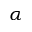Convert formula to latex. <formula><loc_0><loc_0><loc_500><loc_500>\alpha</formula> 